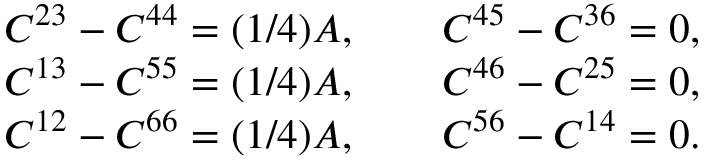<formula> <loc_0><loc_0><loc_500><loc_500>\begin{array} { r } { C ^ { 2 3 } - C ^ { 4 4 } = ( 1 / 4 ) A , \quad C ^ { 4 5 } - C ^ { 3 6 } = 0 , } \\ { C ^ { 1 3 } - C ^ { 5 5 } = ( 1 / 4 ) A , \quad C ^ { 4 6 } - C ^ { 2 5 } = 0 , } \\ { C ^ { 1 2 } - C ^ { 6 6 } = ( 1 / 4 ) A , \quad C ^ { 5 6 } - C ^ { 1 4 } = 0 . } \end{array}</formula> 